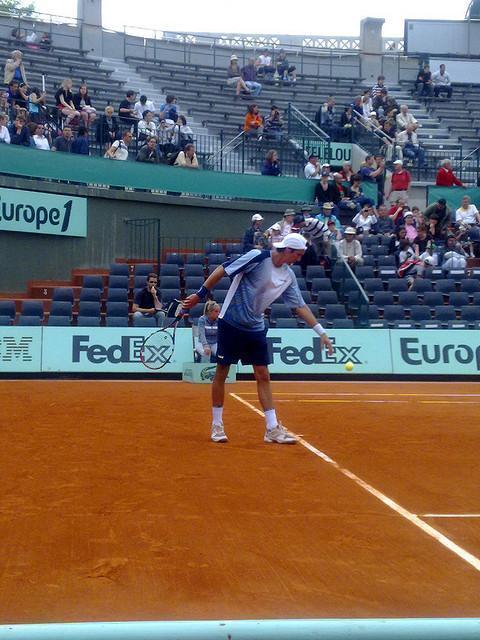How many cars are on the right of the horses and riders?
Give a very brief answer. 0. 